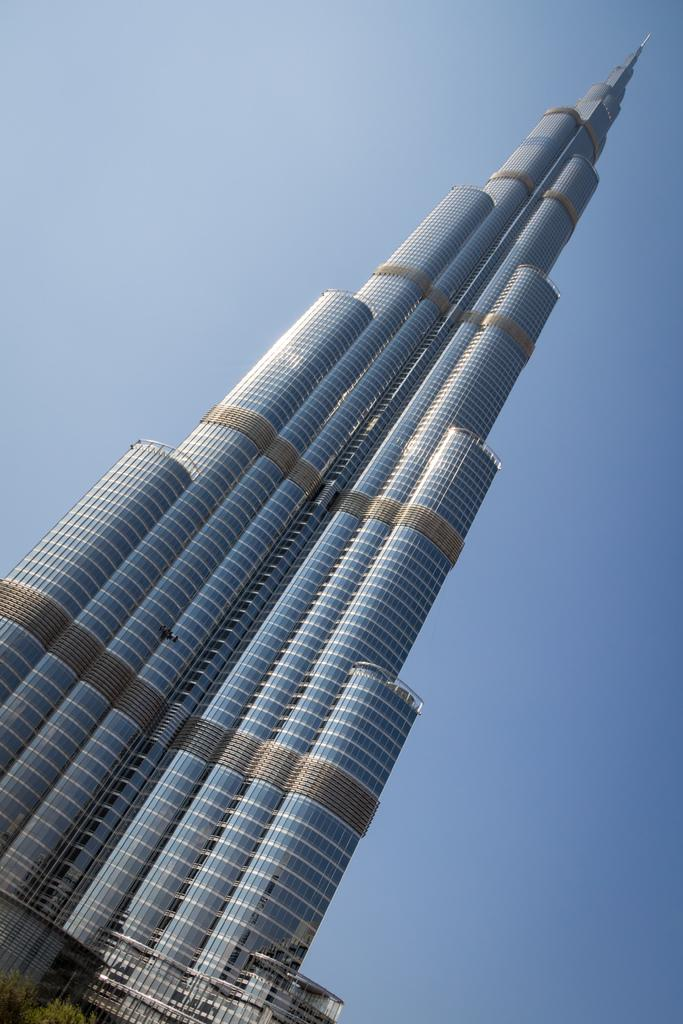What is the main structure in the image? There is a big building in the image. What color is the sky in the image? The sky is blue in the image. What type of wine is being served in the image? There is no wine present in the image. How does the building look from the back in the image? The provided facts do not give information about the building's appearance from the back, so it cannot be answered definitively. 